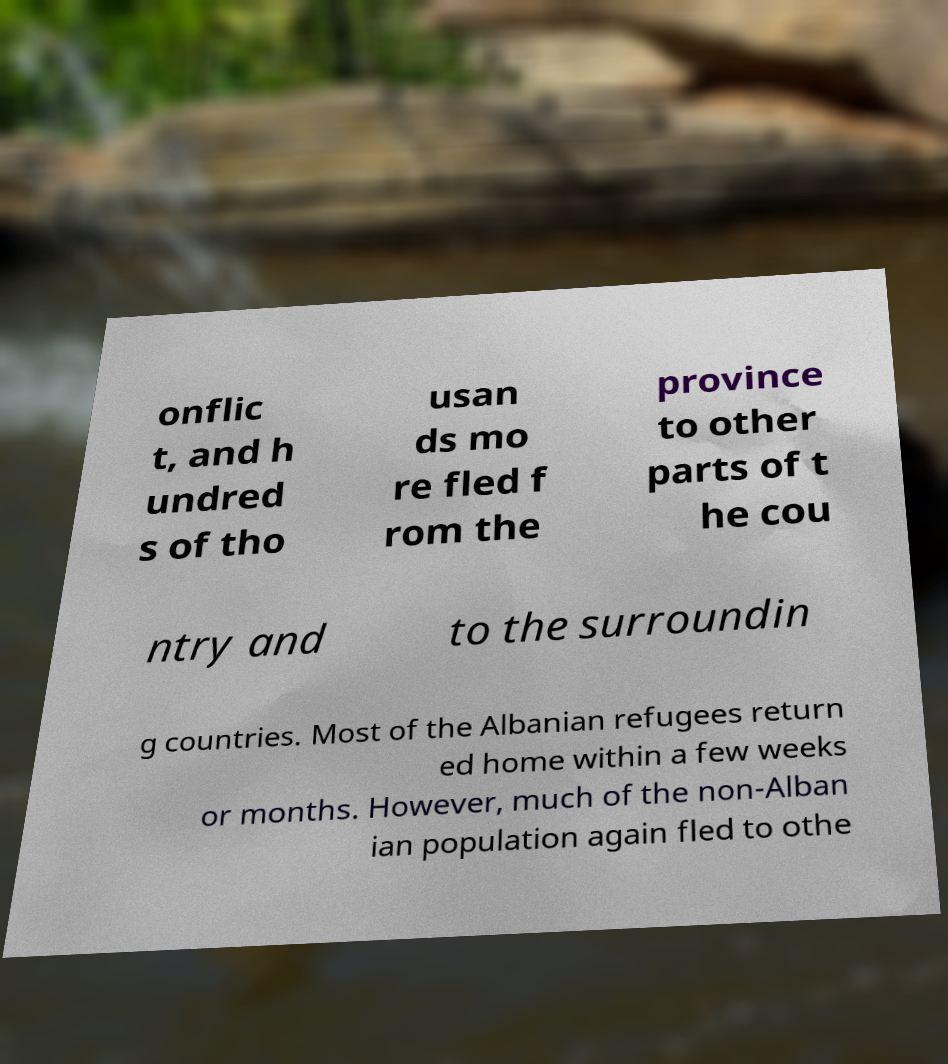Can you accurately transcribe the text from the provided image for me? onflic t, and h undred s of tho usan ds mo re fled f rom the province to other parts of t he cou ntry and to the surroundin g countries. Most of the Albanian refugees return ed home within a few weeks or months. However, much of the non-Alban ian population again fled to othe 